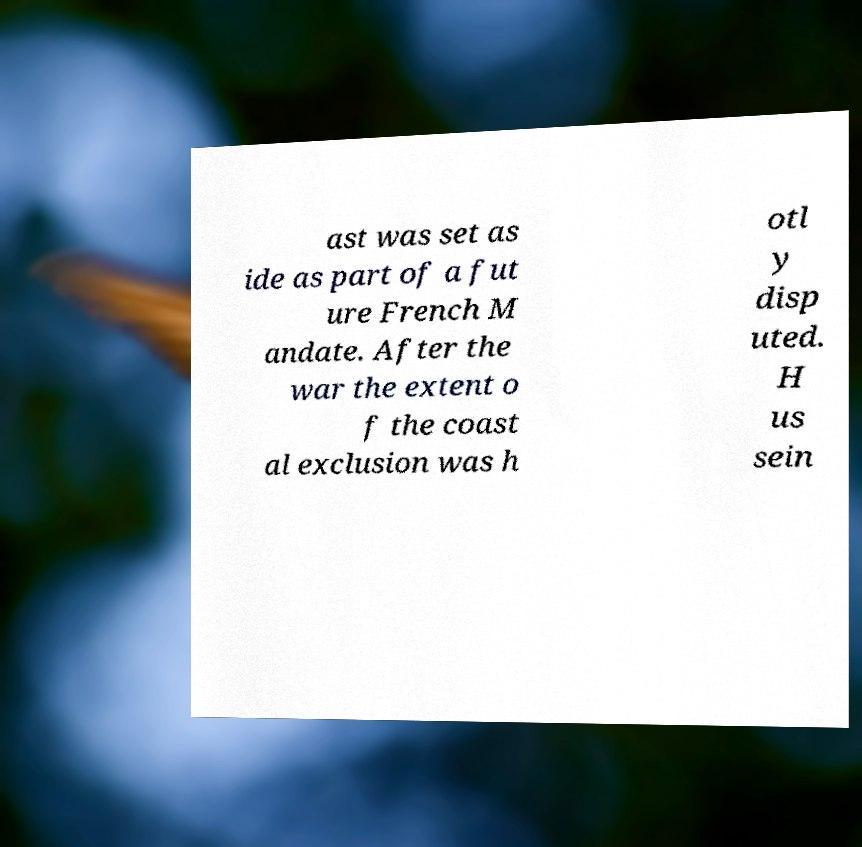For documentation purposes, I need the text within this image transcribed. Could you provide that? ast was set as ide as part of a fut ure French M andate. After the war the extent o f the coast al exclusion was h otl y disp uted. H us sein 